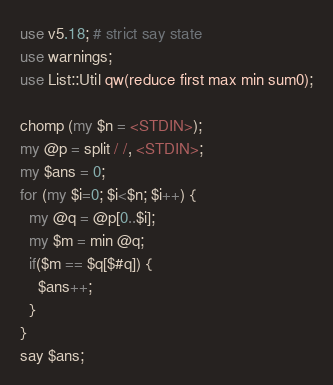<code> <loc_0><loc_0><loc_500><loc_500><_Perl_>use v5.18; # strict say state
use warnings;
use List::Util qw(reduce first max min sum0);

chomp (my $n = <STDIN>);
my @p = split / /, <STDIN>;
my $ans = 0;
for (my $i=0; $i<$n; $i++) {
  my @q = @p[0..$i];
  my $m = min @q;
  if($m == $q[$#q]) {
    $ans++;
  }
}
say $ans;</code> 